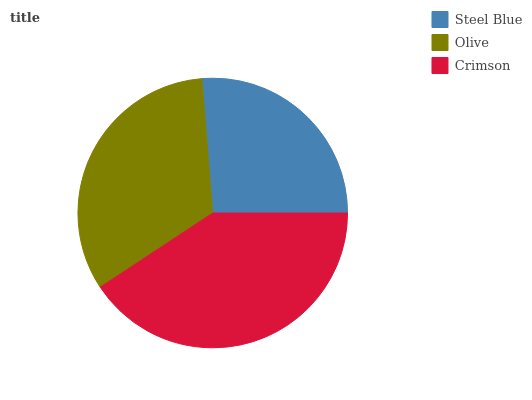Is Steel Blue the minimum?
Answer yes or no. Yes. Is Crimson the maximum?
Answer yes or no. Yes. Is Olive the minimum?
Answer yes or no. No. Is Olive the maximum?
Answer yes or no. No. Is Olive greater than Steel Blue?
Answer yes or no. Yes. Is Steel Blue less than Olive?
Answer yes or no. Yes. Is Steel Blue greater than Olive?
Answer yes or no. No. Is Olive less than Steel Blue?
Answer yes or no. No. Is Olive the high median?
Answer yes or no. Yes. Is Olive the low median?
Answer yes or no. Yes. Is Crimson the high median?
Answer yes or no. No. Is Steel Blue the low median?
Answer yes or no. No. 